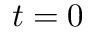Convert formula to latex. <formula><loc_0><loc_0><loc_500><loc_500>t = 0</formula> 